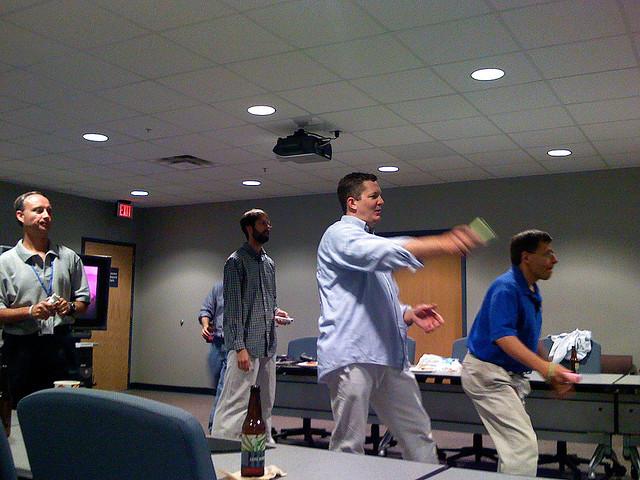Why are they standing?
Give a very brief answer. Playing video games. What gaming platform are they playing?
Short answer required. Wii. Are all the people men?
Write a very short answer. Yes. 